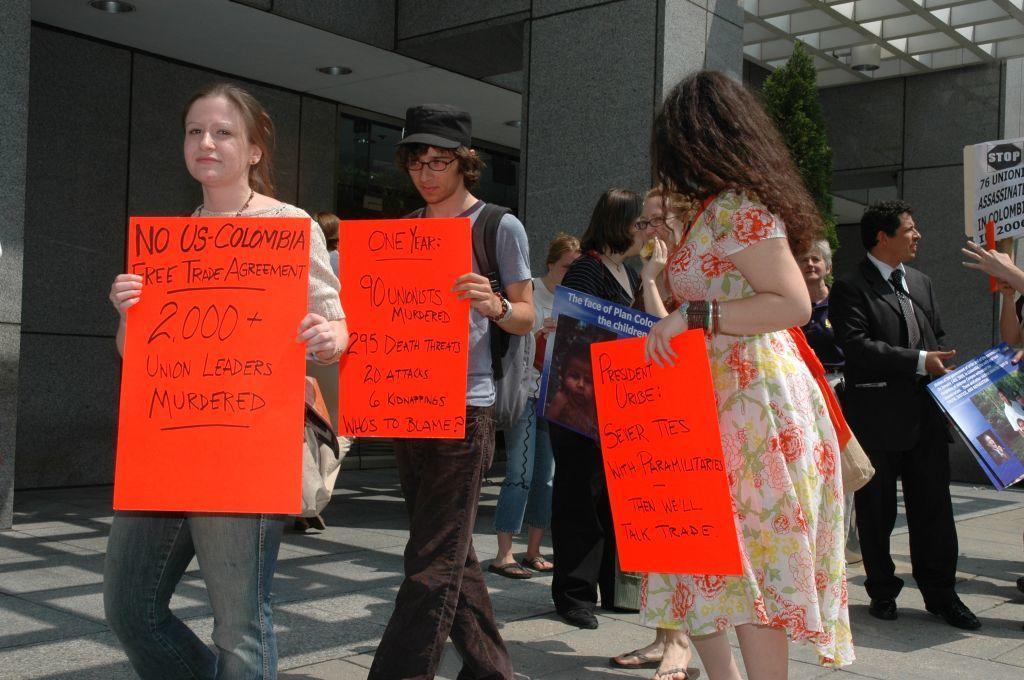Could you give a brief overview of what you see in this image? In this picture there are group of people. On the left side of the image there are two persons holding the pluck cards and walking and there are group of people standing and holding the pluck cards. At the back there is a building and tree. There is a text on the pluck cards. 